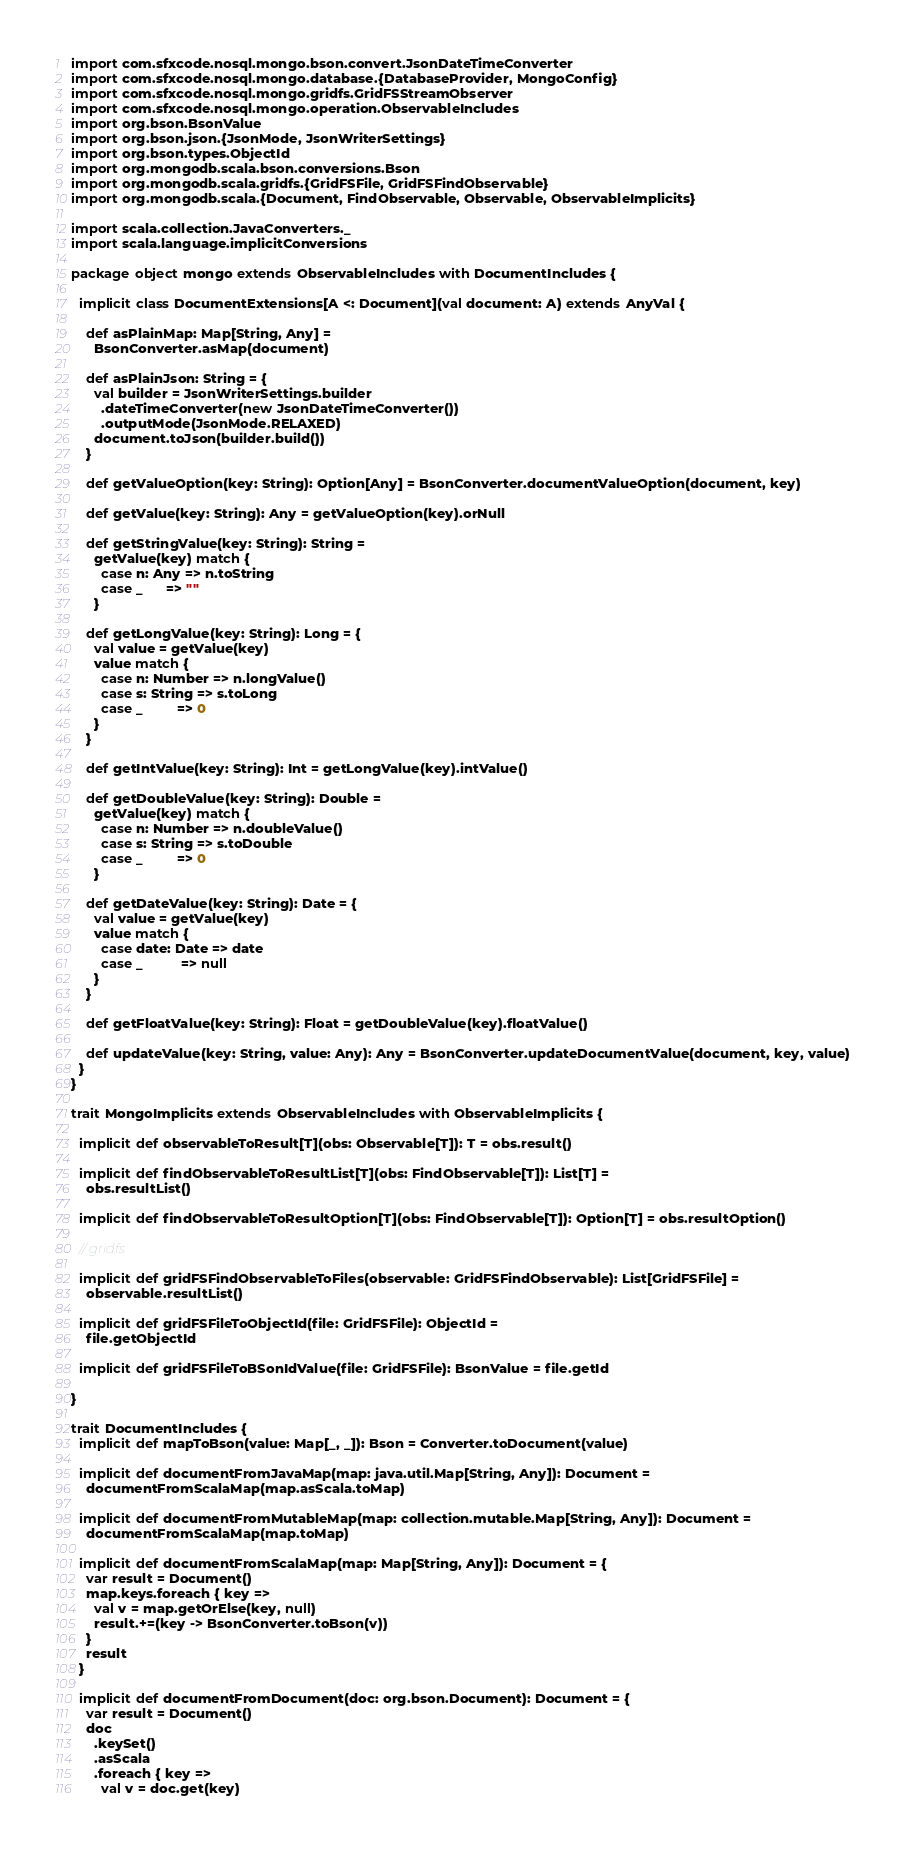<code> <loc_0><loc_0><loc_500><loc_500><_Scala_>import com.sfxcode.nosql.mongo.bson.convert.JsonDateTimeConverter
import com.sfxcode.nosql.mongo.database.{DatabaseProvider, MongoConfig}
import com.sfxcode.nosql.mongo.gridfs.GridFSStreamObserver
import com.sfxcode.nosql.mongo.operation.ObservableIncludes
import org.bson.BsonValue
import org.bson.json.{JsonMode, JsonWriterSettings}
import org.bson.types.ObjectId
import org.mongodb.scala.bson.conversions.Bson
import org.mongodb.scala.gridfs.{GridFSFile, GridFSFindObservable}
import org.mongodb.scala.{Document, FindObservable, Observable, ObservableImplicits}

import scala.collection.JavaConverters._
import scala.language.implicitConversions

package object mongo extends ObservableIncludes with DocumentIncludes {

  implicit class DocumentExtensions[A <: Document](val document: A) extends AnyVal {

    def asPlainMap: Map[String, Any] =
      BsonConverter.asMap(document)

    def asPlainJson: String = {
      val builder = JsonWriterSettings.builder
        .dateTimeConverter(new JsonDateTimeConverter())
        .outputMode(JsonMode.RELAXED)
      document.toJson(builder.build())
    }

    def getValueOption(key: String): Option[Any] = BsonConverter.documentValueOption(document, key)

    def getValue(key: String): Any = getValueOption(key).orNull

    def getStringValue(key: String): String =
      getValue(key) match {
        case n: Any => n.toString
        case _      => ""
      }

    def getLongValue(key: String): Long = {
      val value = getValue(key)
      value match {
        case n: Number => n.longValue()
        case s: String => s.toLong
        case _         => 0
      }
    }

    def getIntValue(key: String): Int = getLongValue(key).intValue()

    def getDoubleValue(key: String): Double =
      getValue(key) match {
        case n: Number => n.doubleValue()
        case s: String => s.toDouble
        case _         => 0
      }

    def getDateValue(key: String): Date = {
      val value = getValue(key)
      value match {
        case date: Date => date
        case _          => null
      }
    }

    def getFloatValue(key: String): Float = getDoubleValue(key).floatValue()

    def updateValue(key: String, value: Any): Any = BsonConverter.updateDocumentValue(document, key, value)
  }
}

trait MongoImplicits extends ObservableIncludes with ObservableImplicits {

  implicit def observableToResult[T](obs: Observable[T]): T = obs.result()

  implicit def findObservableToResultList[T](obs: FindObservable[T]): List[T] =
    obs.resultList()

  implicit def findObservableToResultOption[T](obs: FindObservable[T]): Option[T] = obs.resultOption()

  // gridfs

  implicit def gridFSFindObservableToFiles(observable: GridFSFindObservable): List[GridFSFile] =
    observable.resultList()

  implicit def gridFSFileToObjectId(file: GridFSFile): ObjectId =
    file.getObjectId

  implicit def gridFSFileToBSonIdValue(file: GridFSFile): BsonValue = file.getId

}

trait DocumentIncludes {
  implicit def mapToBson(value: Map[_, _]): Bson = Converter.toDocument(value)

  implicit def documentFromJavaMap(map: java.util.Map[String, Any]): Document =
    documentFromScalaMap(map.asScala.toMap)

  implicit def documentFromMutableMap(map: collection.mutable.Map[String, Any]): Document =
    documentFromScalaMap(map.toMap)

  implicit def documentFromScalaMap(map: Map[String, Any]): Document = {
    var result = Document()
    map.keys.foreach { key =>
      val v = map.getOrElse(key, null)
      result.+=(key -> BsonConverter.toBson(v))
    }
    result
  }

  implicit def documentFromDocument(doc: org.bson.Document): Document = {
    var result = Document()
    doc
      .keySet()
      .asScala
      .foreach { key =>
        val v = doc.get(key)</code> 